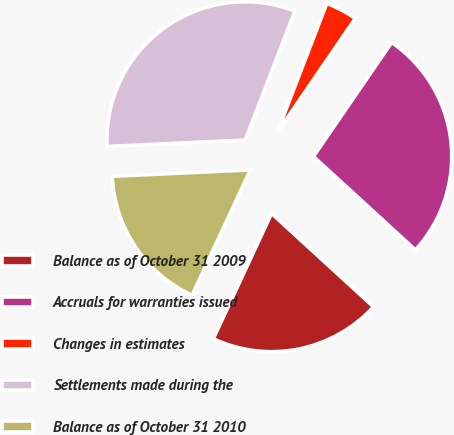Convert chart. <chart><loc_0><loc_0><loc_500><loc_500><pie_chart><fcel>Balance as of October 31 2009<fcel>Accruals for warranties issued<fcel>Changes in estimates<fcel>Settlements made during the<fcel>Balance as of October 31 2010<nl><fcel>20.12%<fcel>27.24%<fcel>3.72%<fcel>31.58%<fcel>17.34%<nl></chart> 